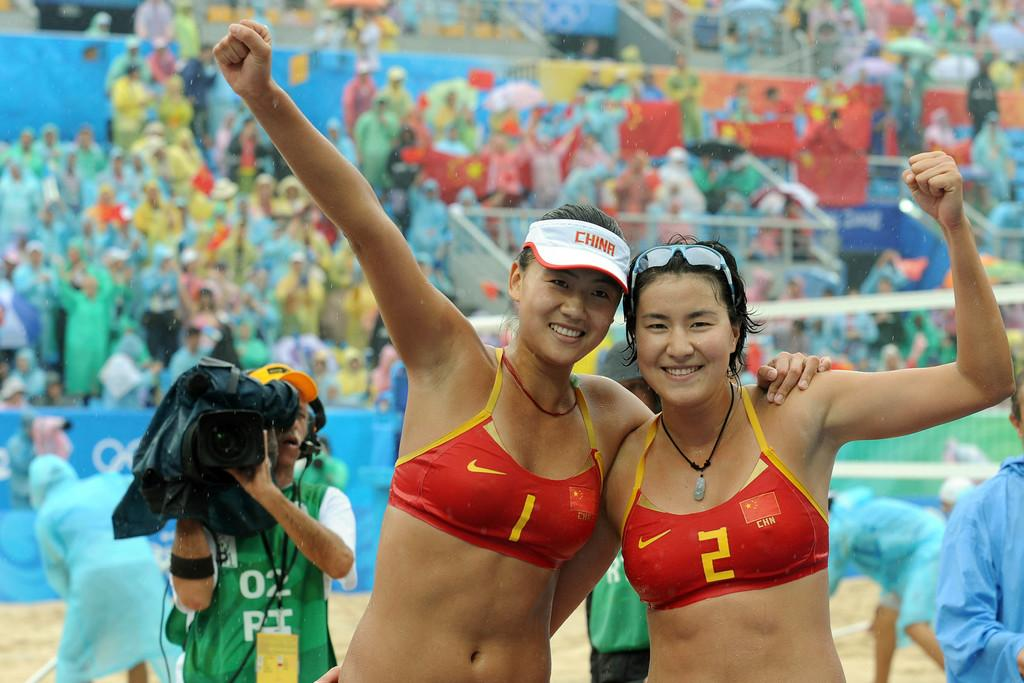<image>
Offer a succinct explanation of the picture presented. A woman in a red bikini has the number 1 on the front. 